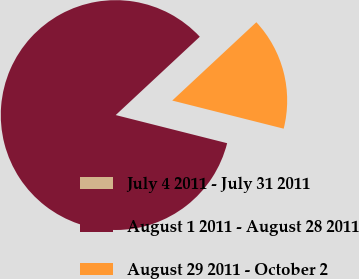Convert chart. <chart><loc_0><loc_0><loc_500><loc_500><pie_chart><fcel>July 4 2011 - July 31 2011<fcel>August 1 2011 - August 28 2011<fcel>August 29 2011 - October 2<nl><fcel>0.0%<fcel>84.13%<fcel>15.87%<nl></chart> 